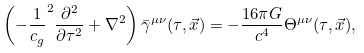Convert formula to latex. <formula><loc_0><loc_0><loc_500><loc_500>\left ( - \frac { 1 } { c _ { g } } ^ { 2 } \frac { \partial ^ { 2 } } { \partial \tau ^ { 2 } } + \nabla ^ { 2 } \right ) \bar { \gamma } ^ { \mu \nu } ( \tau , \vec { x } ) = - \frac { 1 6 \pi G } { c ^ { 4 } } \Theta ^ { \mu \nu } ( \tau , \vec { x } ) ,</formula> 